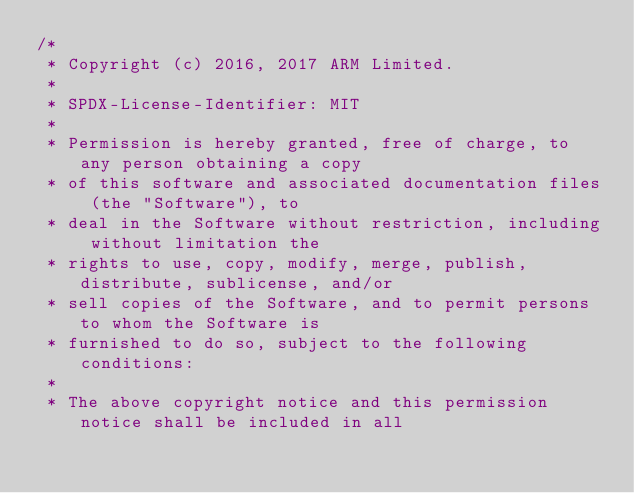Convert code to text. <code><loc_0><loc_0><loc_500><loc_500><_C_>/*
 * Copyright (c) 2016, 2017 ARM Limited.
 *
 * SPDX-License-Identifier: MIT
 *
 * Permission is hereby granted, free of charge, to any person obtaining a copy
 * of this software and associated documentation files (the "Software"), to
 * deal in the Software without restriction, including without limitation the
 * rights to use, copy, modify, merge, publish, distribute, sublicense, and/or
 * sell copies of the Software, and to permit persons to whom the Software is
 * furnished to do so, subject to the following conditions:
 *
 * The above copyright notice and this permission notice shall be included in all</code> 